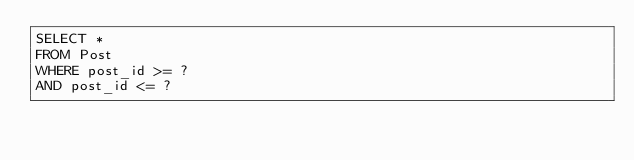<code> <loc_0><loc_0><loc_500><loc_500><_SQL_>SELECT *
FROM Post
WHERE post_id >= ?
AND post_id <= ?</code> 